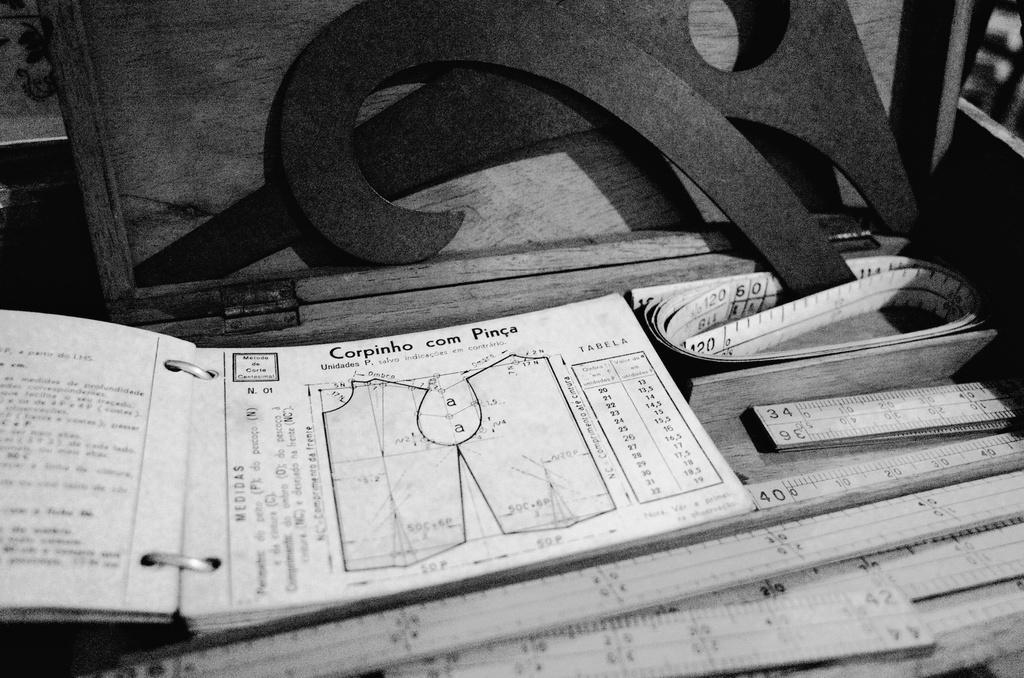In one or two sentences, can you explain what this image depicts? In the picture I can see few wooden scales and there is a book which has something written on it and a measuring tape in front of the wooden scale and there are few other objects in the background. 